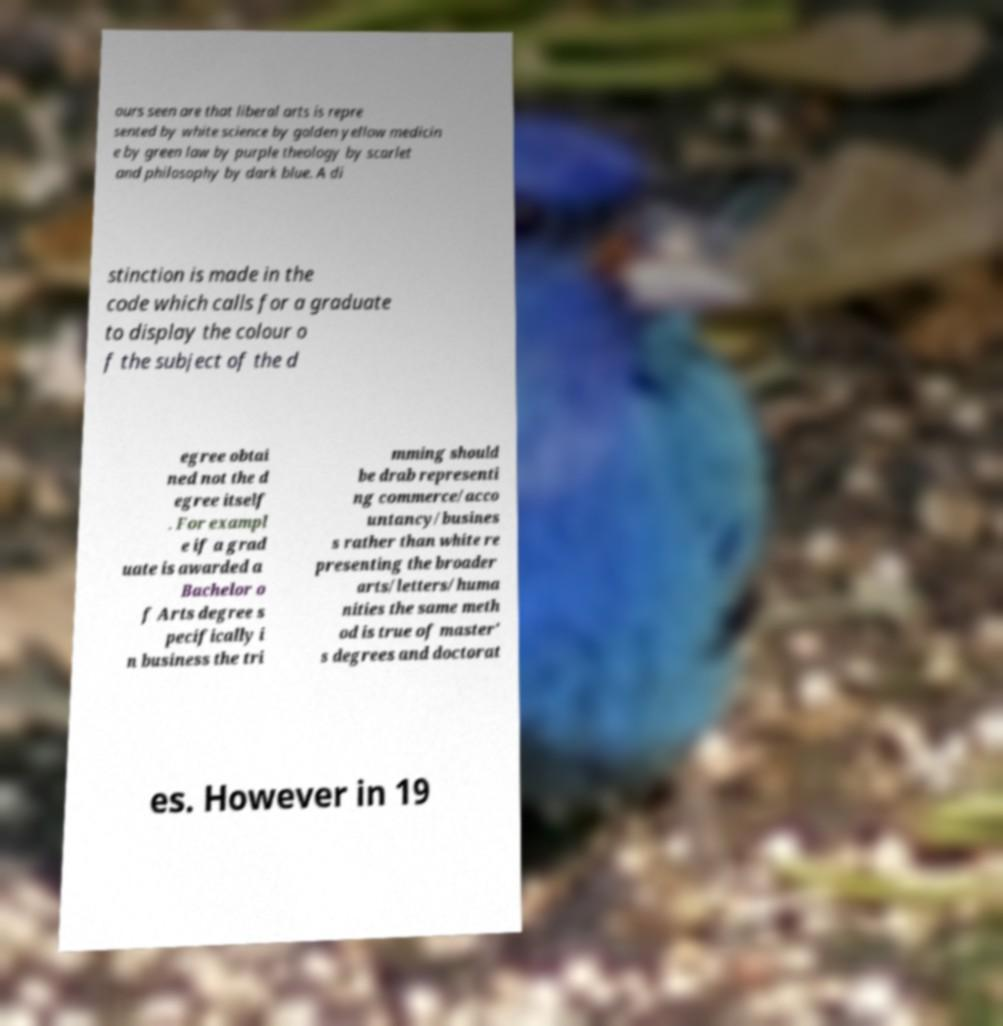Can you accurately transcribe the text from the provided image for me? ours seen are that liberal arts is repre sented by white science by golden yellow medicin e by green law by purple theology by scarlet and philosophy by dark blue. A di stinction is made in the code which calls for a graduate to display the colour o f the subject of the d egree obtai ned not the d egree itself . For exampl e if a grad uate is awarded a Bachelor o f Arts degree s pecifically i n business the tri mming should be drab representi ng commerce/acco untancy/busines s rather than white re presenting the broader arts/letters/huma nities the same meth od is true of master' s degrees and doctorat es. However in 19 